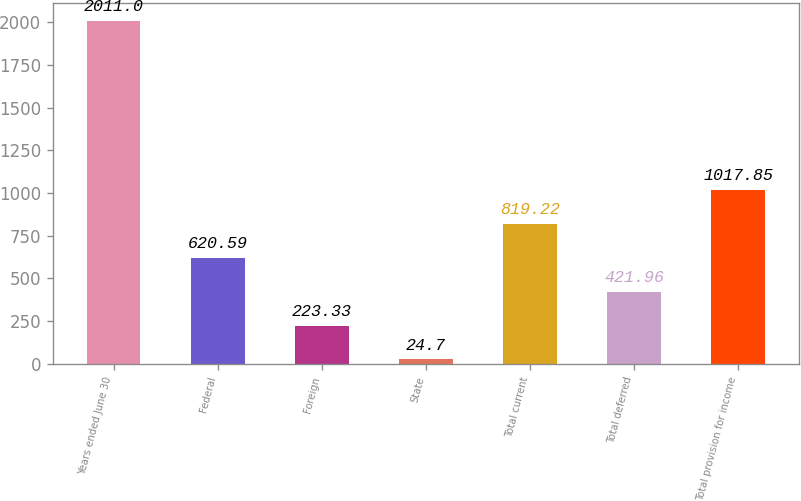Convert chart to OTSL. <chart><loc_0><loc_0><loc_500><loc_500><bar_chart><fcel>Years ended June 30<fcel>Federal<fcel>Foreign<fcel>State<fcel>Total current<fcel>Total deferred<fcel>Total provision for income<nl><fcel>2011<fcel>620.59<fcel>223.33<fcel>24.7<fcel>819.22<fcel>421.96<fcel>1017.85<nl></chart> 